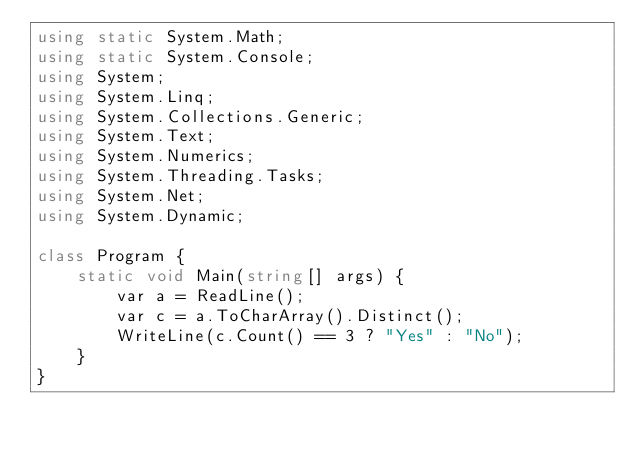<code> <loc_0><loc_0><loc_500><loc_500><_C#_>using static System.Math;
using static System.Console;
using System;
using System.Linq;
using System.Collections.Generic;
using System.Text;
using System.Numerics;
using System.Threading.Tasks;
using System.Net;
using System.Dynamic;

class Program {
    static void Main(string[] args) {
        var a = ReadLine();
        var c = a.ToCharArray().Distinct();
        WriteLine(c.Count() == 3 ? "Yes" : "No");
    }
}</code> 